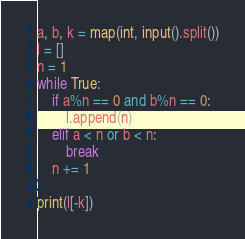<code> <loc_0><loc_0><loc_500><loc_500><_Python_>a, b, k = map(int, input().split())
l = []
n = 1
while True:
    if a%n == 0 and b%n == 0:
        l.append(n)
    elif a < n or b < n:
        break
    n += 1

print(l[-k])</code> 